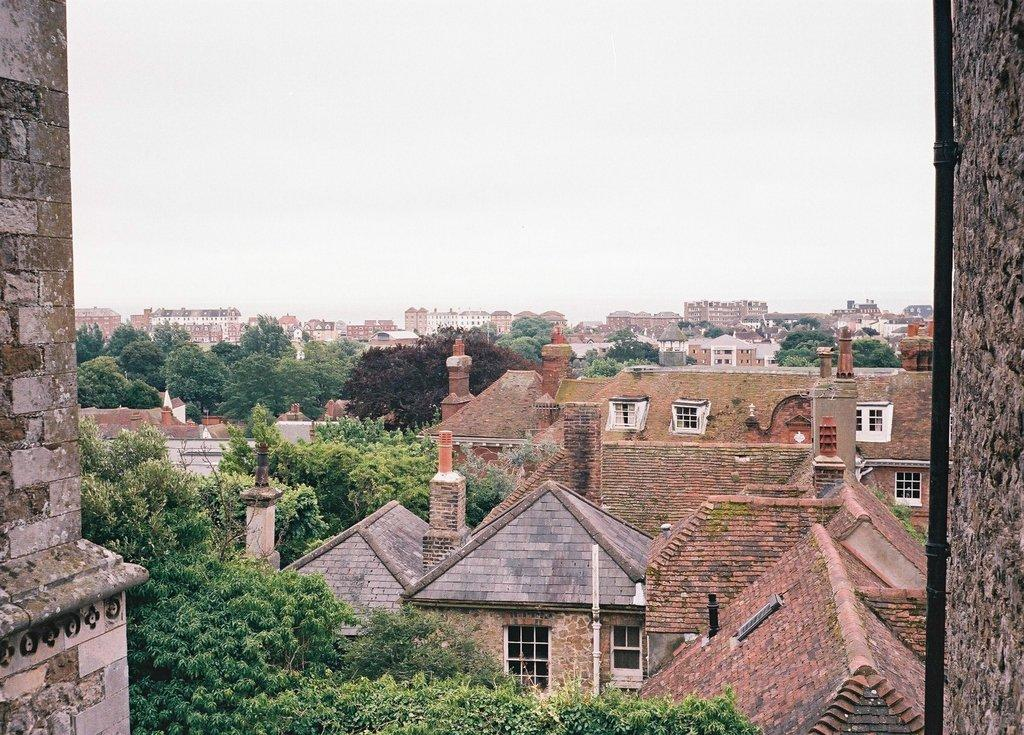What type of natural vegetation is visible in the image? There are trees in the image. What type of man-made structures can be seen in the image? There are buildings in the image. What is the condition of the sky in the image? The sky is cloudy in the image. Are there any fairies visible among the trees in the image? There are no fairies visible among the trees in the image. What type of education is being represented in the image? The image does not depict any educational content or context. 